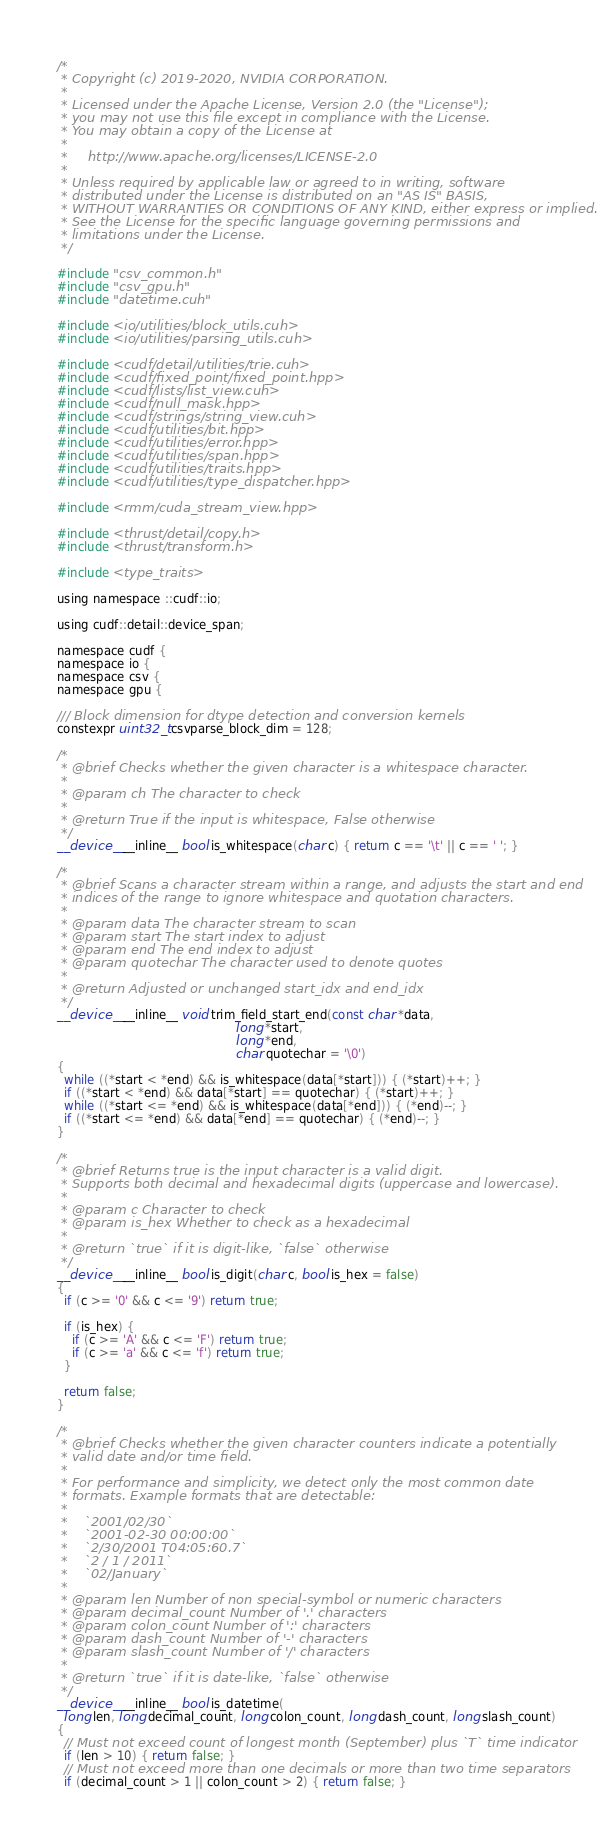Convert code to text. <code><loc_0><loc_0><loc_500><loc_500><_Cuda_>/*
 * Copyright (c) 2019-2020, NVIDIA CORPORATION.
 *
 * Licensed under the Apache License, Version 2.0 (the "License");
 * you may not use this file except in compliance with the License.
 * You may obtain a copy of the License at
 *
 *     http://www.apache.org/licenses/LICENSE-2.0
 *
 * Unless required by applicable law or agreed to in writing, software
 * distributed under the License is distributed on an "AS IS" BASIS,
 * WITHOUT WARRANTIES OR CONDITIONS OF ANY KIND, either express or implied.
 * See the License for the specific language governing permissions and
 * limitations under the License.
 */

#include "csv_common.h"
#include "csv_gpu.h"
#include "datetime.cuh"

#include <io/utilities/block_utils.cuh>
#include <io/utilities/parsing_utils.cuh>

#include <cudf/detail/utilities/trie.cuh>
#include <cudf/fixed_point/fixed_point.hpp>
#include <cudf/lists/list_view.cuh>
#include <cudf/null_mask.hpp>
#include <cudf/strings/string_view.cuh>
#include <cudf/utilities/bit.hpp>
#include <cudf/utilities/error.hpp>
#include <cudf/utilities/span.hpp>
#include <cudf/utilities/traits.hpp>
#include <cudf/utilities/type_dispatcher.hpp>

#include <rmm/cuda_stream_view.hpp>

#include <thrust/detail/copy.h>
#include <thrust/transform.h>

#include <type_traits>

using namespace ::cudf::io;

using cudf::detail::device_span;

namespace cudf {
namespace io {
namespace csv {
namespace gpu {

/// Block dimension for dtype detection and conversion kernels
constexpr uint32_t csvparse_block_dim = 128;

/*
 * @brief Checks whether the given character is a whitespace character.
 *
 * @param ch The character to check
 *
 * @return True if the input is whitespace, False otherwise
 */
__device__ __inline__ bool is_whitespace(char c) { return c == '\t' || c == ' '; }

/*
 * @brief Scans a character stream within a range, and adjusts the start and end
 * indices of the range to ignore whitespace and quotation characters.
 *
 * @param data The character stream to scan
 * @param start The start index to adjust
 * @param end The end index to adjust
 * @param quotechar The character used to denote quotes
 *
 * @return Adjusted or unchanged start_idx and end_idx
 */
__device__ __inline__ void trim_field_start_end(const char *data,
                                                long *start,
                                                long *end,
                                                char quotechar = '\0')
{
  while ((*start < *end) && is_whitespace(data[*start])) { (*start)++; }
  if ((*start < *end) && data[*start] == quotechar) { (*start)++; }
  while ((*start <= *end) && is_whitespace(data[*end])) { (*end)--; }
  if ((*start <= *end) && data[*end] == quotechar) { (*end)--; }
}

/*
 * @brief Returns true is the input character is a valid digit.
 * Supports both decimal and hexadecimal digits (uppercase and lowercase).
 *
 * @param c Character to check
 * @param is_hex Whether to check as a hexadecimal
 *
 * @return `true` if it is digit-like, `false` otherwise
 */
__device__ __inline__ bool is_digit(char c, bool is_hex = false)
{
  if (c >= '0' && c <= '9') return true;

  if (is_hex) {
    if (c >= 'A' && c <= 'F') return true;
    if (c >= 'a' && c <= 'f') return true;
  }

  return false;
}

/*
 * @brief Checks whether the given character counters indicate a potentially
 * valid date and/or time field.
 *
 * For performance and simplicity, we detect only the most common date
 * formats. Example formats that are detectable:
 *
 *    `2001/02/30`
 *    `2001-02-30 00:00:00`
 *    `2/30/2001 T04:05:60.7`
 *    `2 / 1 / 2011`
 *    `02/January`
 *
 * @param len Number of non special-symbol or numeric characters
 * @param decimal_count Number of '.' characters
 * @param colon_count Number of ':' characters
 * @param dash_count Number of '-' characters
 * @param slash_count Number of '/' characters
 *
 * @return `true` if it is date-like, `false` otherwise
 */
__device__ __inline__ bool is_datetime(
  long len, long decimal_count, long colon_count, long dash_count, long slash_count)
{
  // Must not exceed count of longest month (September) plus `T` time indicator
  if (len > 10) { return false; }
  // Must not exceed more than one decimals or more than two time separators
  if (decimal_count > 1 || colon_count > 2) { return false; }</code> 